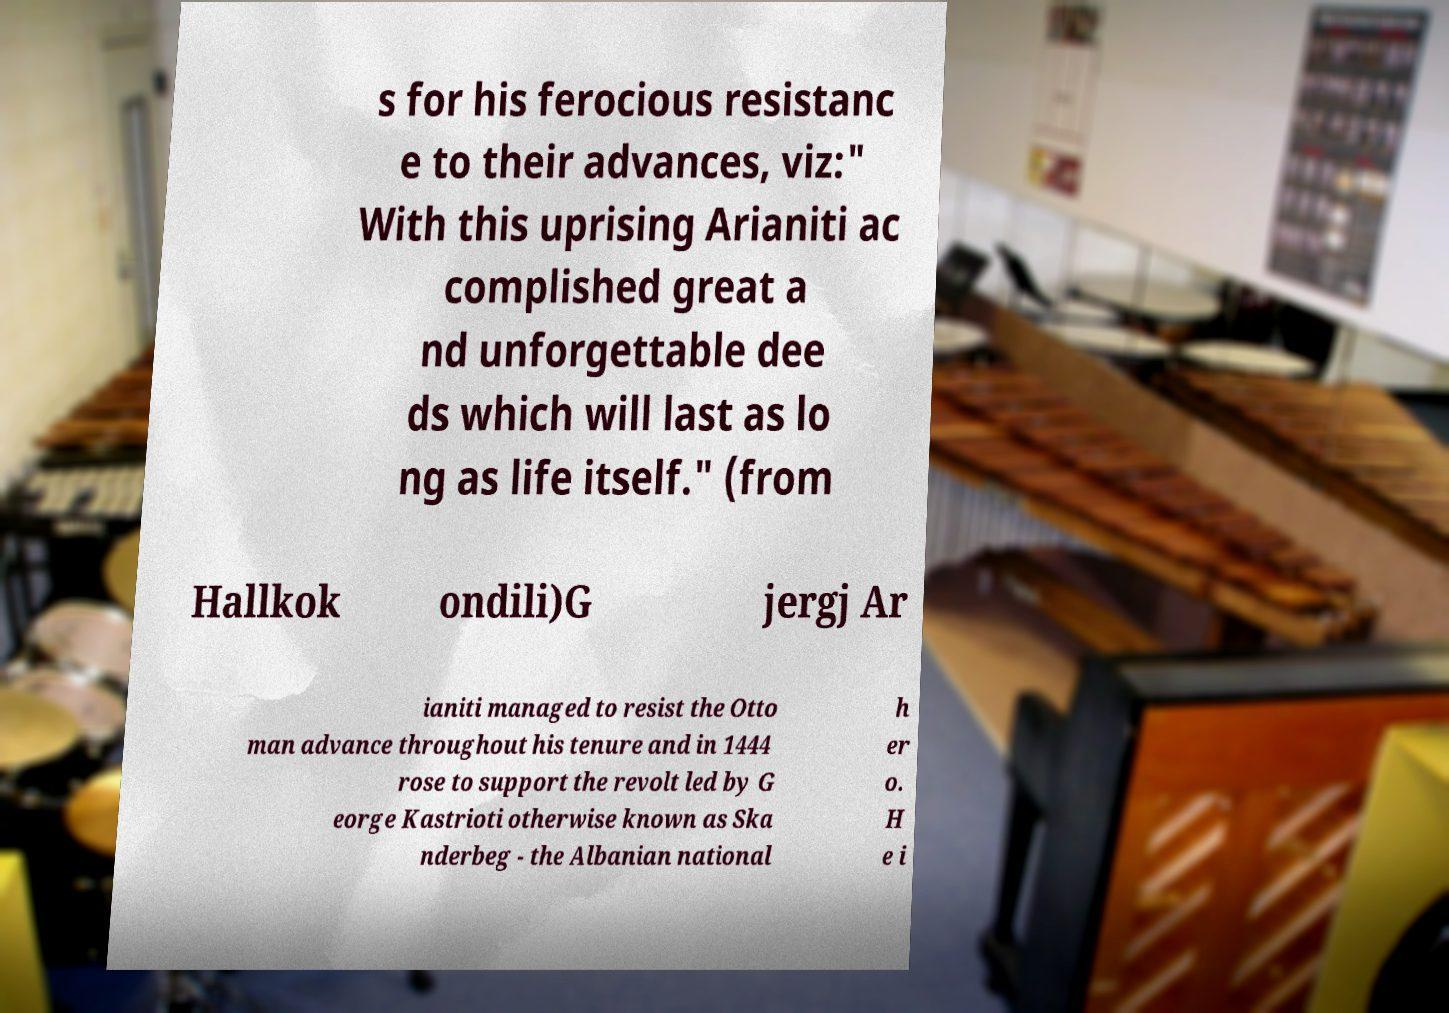What messages or text are displayed in this image? I need them in a readable, typed format. s for his ferocious resistanc e to their advances, viz:" With this uprising Arianiti ac complished great a nd unforgettable dee ds which will last as lo ng as life itself." (from Hallkok ondili)G jergj Ar ianiti managed to resist the Otto man advance throughout his tenure and in 1444 rose to support the revolt led by G eorge Kastrioti otherwise known as Ska nderbeg - the Albanian national h er o. H e i 